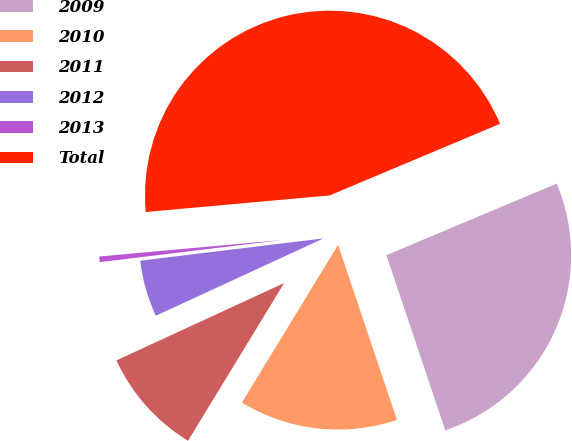Convert chart to OTSL. <chart><loc_0><loc_0><loc_500><loc_500><pie_chart><fcel>2009<fcel>2010<fcel>2011<fcel>2012<fcel>2013<fcel>Total<nl><fcel>26.17%<fcel>13.87%<fcel>9.41%<fcel>4.95%<fcel>0.49%<fcel>45.09%<nl></chart> 